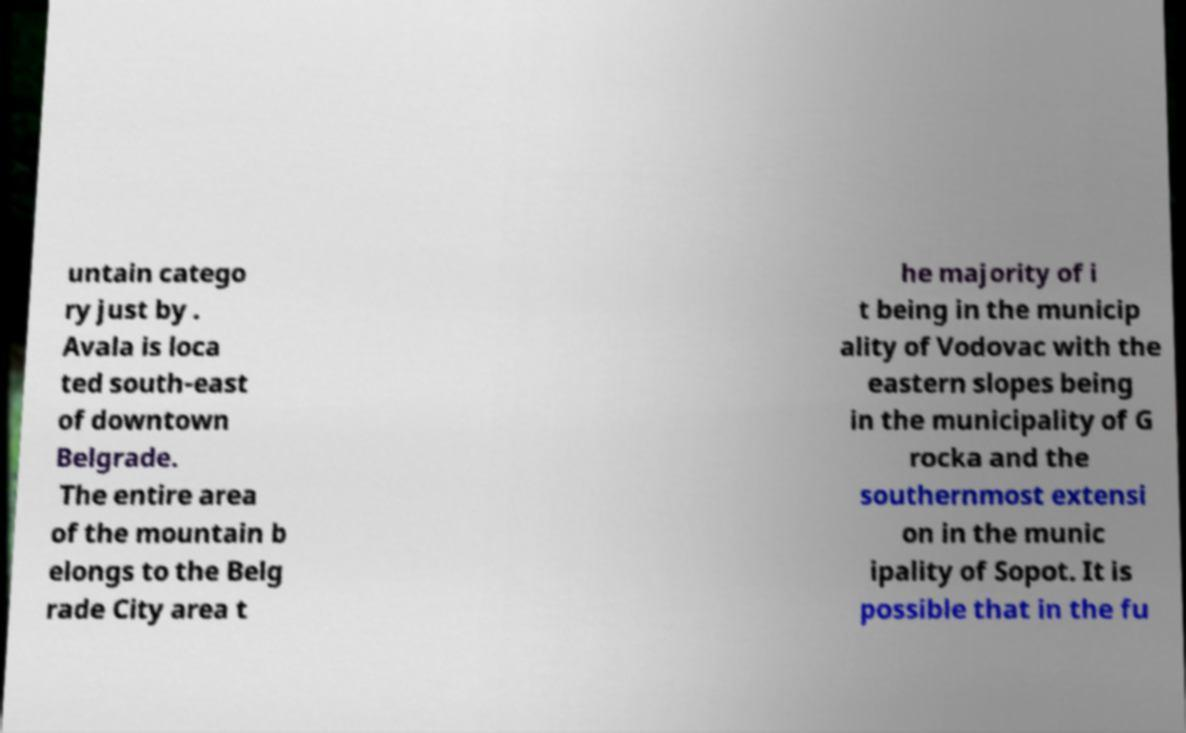Could you assist in decoding the text presented in this image and type it out clearly? untain catego ry just by . Avala is loca ted south-east of downtown Belgrade. The entire area of the mountain b elongs to the Belg rade City area t he majority of i t being in the municip ality of Vodovac with the eastern slopes being in the municipality of G rocka and the southernmost extensi on in the munic ipality of Sopot. It is possible that in the fu 